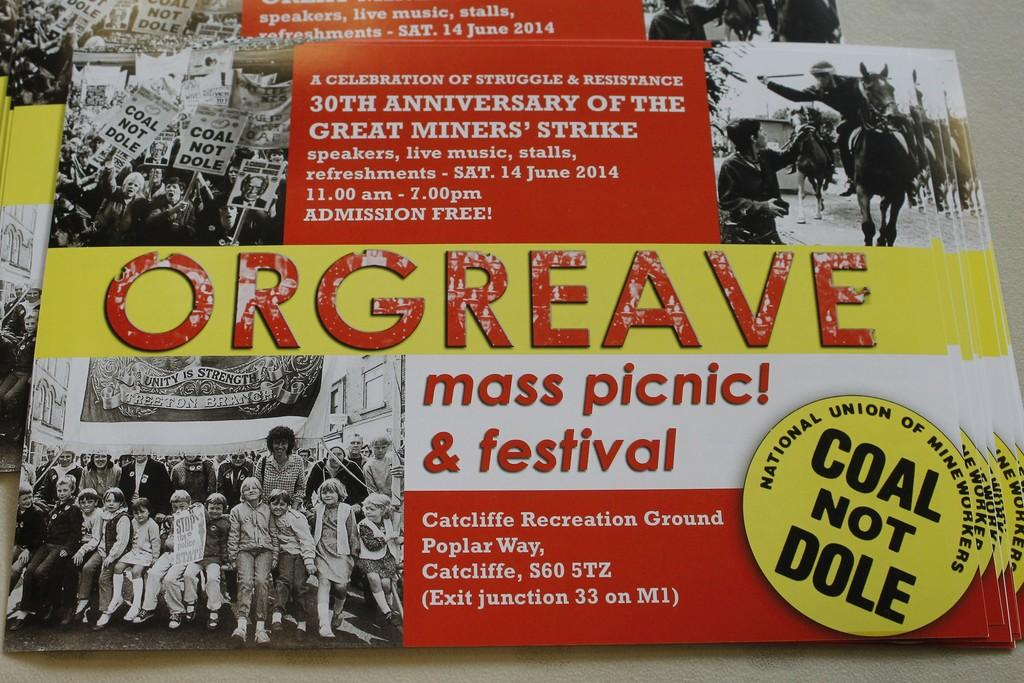Provide a one-sentence caption for the provided image. A poster for an event commemorating the Great Miners Strike includes black and white photos from the original event. 